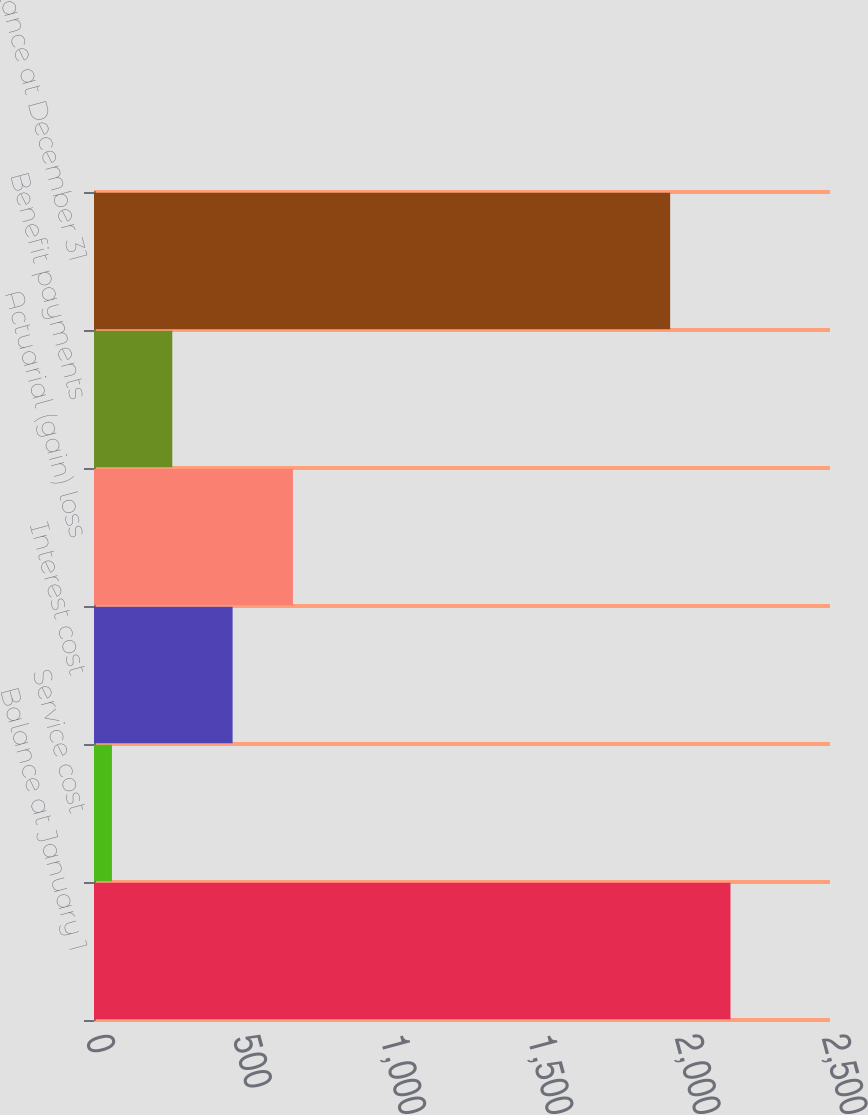Convert chart. <chart><loc_0><loc_0><loc_500><loc_500><bar_chart><fcel>Balance at January 1<fcel>Service cost<fcel>Interest cost<fcel>Actuarial (gain) loss<fcel>Benefit payments<fcel>Balance at December 31<nl><fcel>2161.9<fcel>61<fcel>470.8<fcel>675.7<fcel>265.9<fcel>1957<nl></chart> 